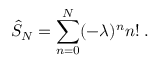<formula> <loc_0><loc_0><loc_500><loc_500>\hat { S } _ { N } = \sum _ { n = 0 } ^ { N } ( - \lambda ) ^ { n } n ! \, .</formula> 